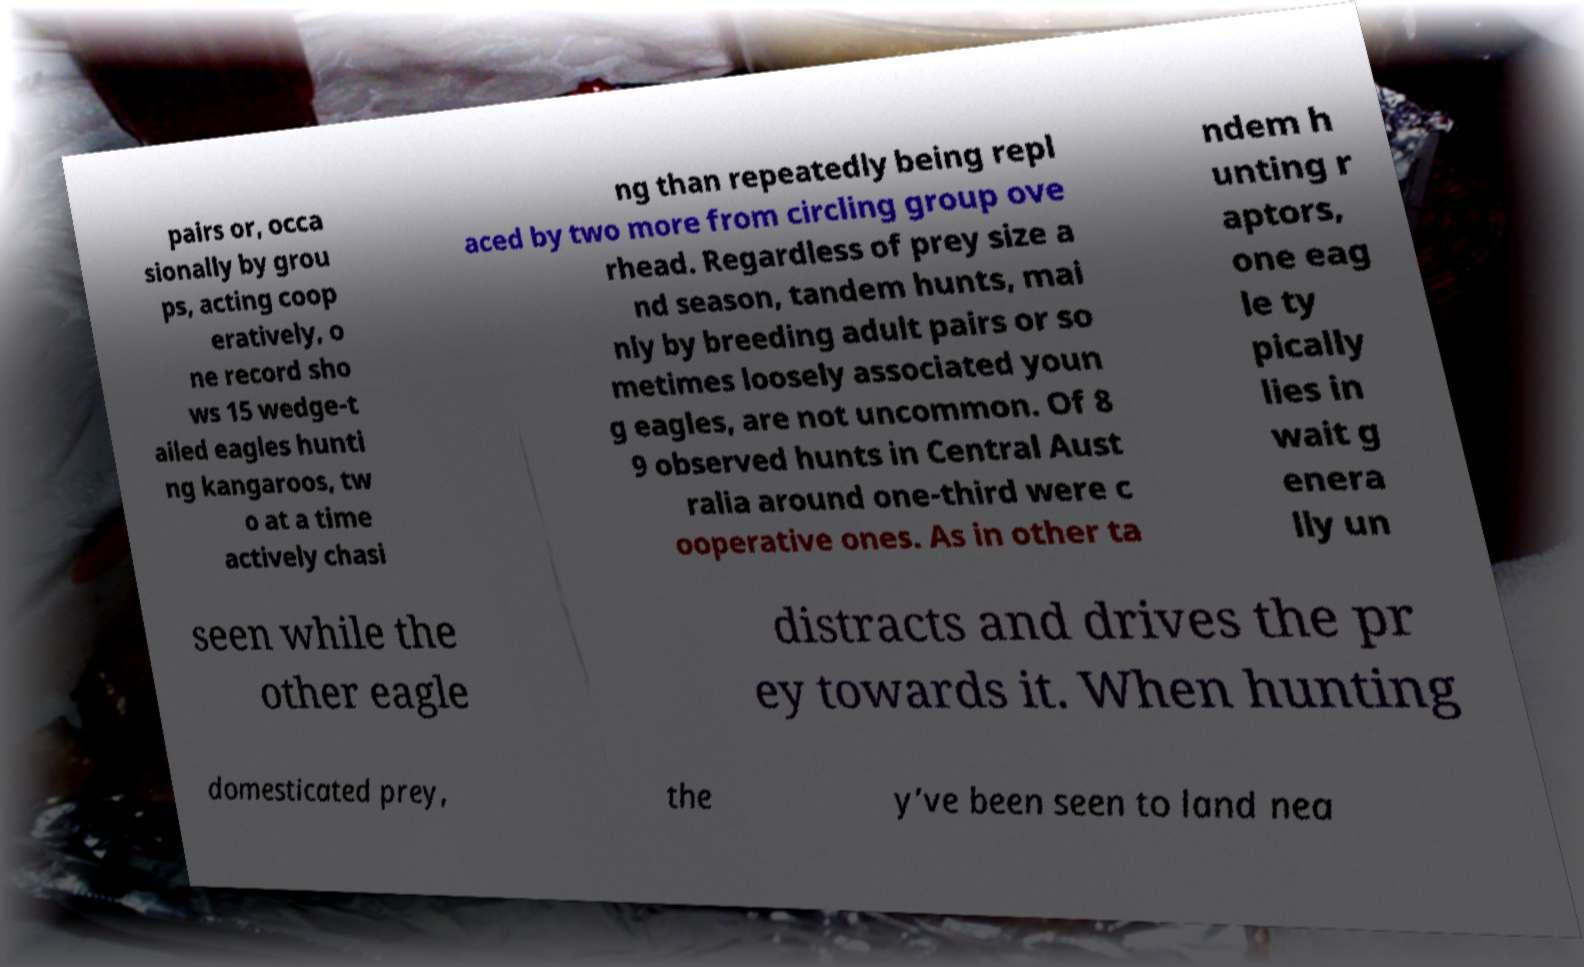There's text embedded in this image that I need extracted. Can you transcribe it verbatim? pairs or, occa sionally by grou ps, acting coop eratively, o ne record sho ws 15 wedge-t ailed eagles hunti ng kangaroos, tw o at a time actively chasi ng than repeatedly being repl aced by two more from circling group ove rhead. Regardless of prey size a nd season, tandem hunts, mai nly by breeding adult pairs or so metimes loosely associated youn g eagles, are not uncommon. Of 8 9 observed hunts in Central Aust ralia around one-third were c ooperative ones. As in other ta ndem h unting r aptors, one eag le ty pically lies in wait g enera lly un seen while the other eagle distracts and drives the pr ey towards it. When hunting domesticated prey, the y’ve been seen to land nea 